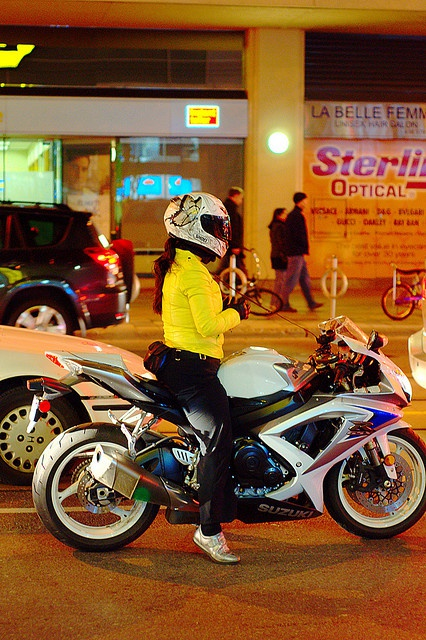Describe the objects in this image and their specific colors. I can see motorcycle in brown, black, maroon, darkgray, and ivory tones, people in brown, black, gold, and maroon tones, car in brown, black, maroon, and tan tones, car in brown, black, orange, and tan tones, and people in brown, black, maroon, and red tones in this image. 